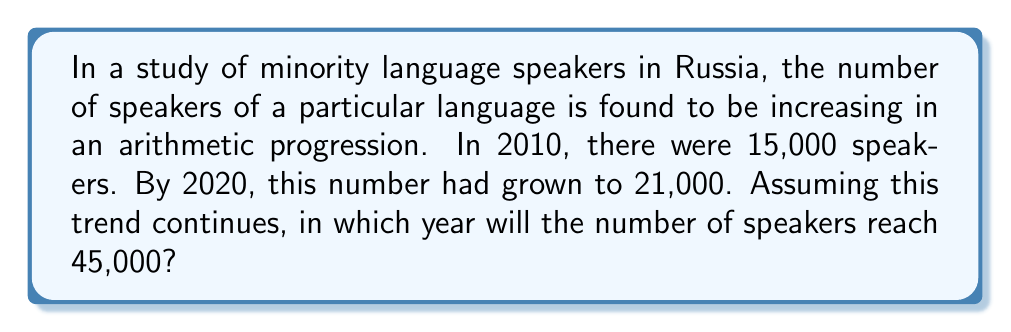Help me with this question. Let's approach this step-by-step:

1) In an arithmetic progression, the difference between each term is constant. Let's call this common difference $d$.

2) We know two terms of our sequence:
   $a_1 = 15,000$ (2010)
   $a_{11} = 21,000$ (2020)

3) The formula for the nth term of an arithmetic sequence is:
   $a_n = a_1 + (n-1)d$

4) We can find $d$ using the given information:
   $21,000 = 15,000 + (11-1)d$
   $21,000 = 15,000 + 10d$
   $6,000 = 10d$
   $d = 600$

5) So, the number of speakers increases by 600 each year.

6) Now, we need to find $n$ when $a_n = 45,000$:
   $45,000 = 15,000 + (n-1)600$
   $30,000 = (n-1)600$
   $50 = n-1$
   $n = 51$

7) Since 2010 is our starting point (n=1), we need to add 50 years to 2010.
Answer: 2060 